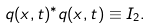<formula> <loc_0><loc_0><loc_500><loc_500>q ( x , t ) ^ { * } q ( x , t ) \equiv I _ { 2 } .</formula> 